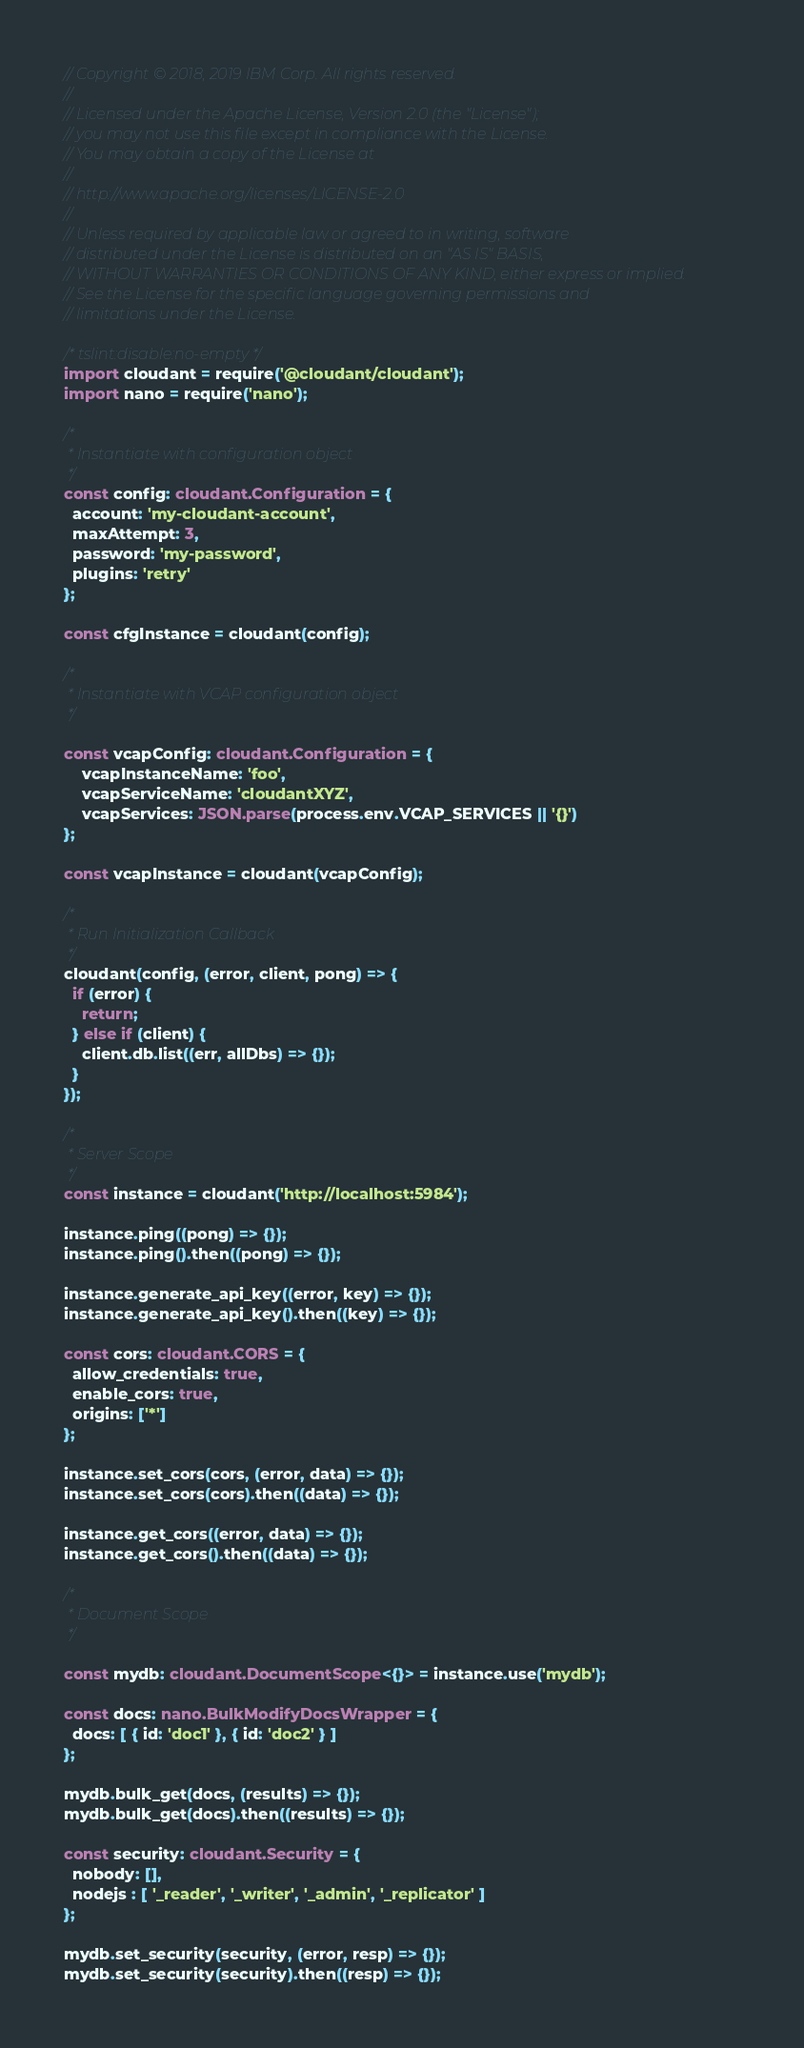<code> <loc_0><loc_0><loc_500><loc_500><_TypeScript_>// Copyright © 2018, 2019 IBM Corp. All rights reserved.
//
// Licensed under the Apache License, Version 2.0 (the "License");
// you may not use this file except in compliance with the License.
// You may obtain a copy of the License at
//
// http://www.apache.org/licenses/LICENSE-2.0
//
// Unless required by applicable law or agreed to in writing, software
// distributed under the License is distributed on an "AS IS" BASIS,
// WITHOUT WARRANTIES OR CONDITIONS OF ANY KIND, either express or implied.
// See the License for the specific language governing permissions and
// limitations under the License.

/* tslint:disable:no-empty */
import cloudant = require('@cloudant/cloudant');
import nano = require('nano');

/*
 * Instantiate with configuration object
 */
const config: cloudant.Configuration = {
  account: 'my-cloudant-account',
  maxAttempt: 3,
  password: 'my-password',
  plugins: 'retry'
};

const cfgInstance = cloudant(config);

/*
 * Instantiate with VCAP configuration object
 */

const vcapConfig: cloudant.Configuration = {
    vcapInstanceName: 'foo',
    vcapServiceName: 'cloudantXYZ',
    vcapServices: JSON.parse(process.env.VCAP_SERVICES || '{}')
};

const vcapInstance = cloudant(vcapConfig);

/*
 * Run Initialization Callback
 */
cloudant(config, (error, client, pong) => {
  if (error) {
    return;
  } else if (client) {
    client.db.list((err, allDbs) => {});
  }
});

/*
 * Server Scope
 */
const instance = cloudant('http://localhost:5984');

instance.ping((pong) => {});
instance.ping().then((pong) => {});

instance.generate_api_key((error, key) => {});
instance.generate_api_key().then((key) => {});

const cors: cloudant.CORS = {
  allow_credentials: true,
  enable_cors: true,
  origins: ['*']
};

instance.set_cors(cors, (error, data) => {});
instance.set_cors(cors).then((data) => {});

instance.get_cors((error, data) => {});
instance.get_cors().then((data) => {});

/*
 * Document Scope
 */

const mydb: cloudant.DocumentScope<{}> = instance.use('mydb');

const docs: nano.BulkModifyDocsWrapper = {
  docs: [ { id: 'doc1' }, { id: 'doc2' } ]
};

mydb.bulk_get(docs, (results) => {});
mydb.bulk_get(docs).then((results) => {});

const security: cloudant.Security = {
  nobody: [],
  nodejs : [ '_reader', '_writer', '_admin', '_replicator' ]
};

mydb.set_security(security, (error, resp) => {});
mydb.set_security(security).then((resp) => {});
</code> 